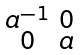<formula> <loc_0><loc_0><loc_500><loc_500>\begin{smallmatrix} a ^ { - 1 } & 0 \\ 0 & a \end{smallmatrix}</formula> 